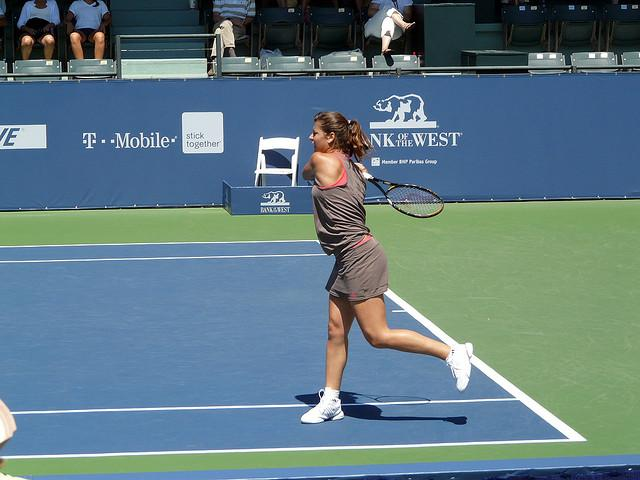What is the middle advertisement on the blue wall about? t-mobile 